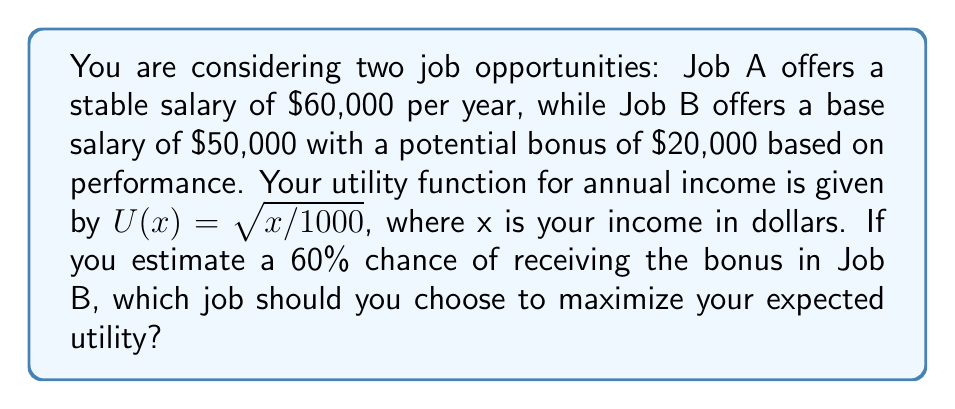Can you solve this math problem? To solve this problem, we need to calculate the expected utility for each job and compare them:

1. Job A:
   - Guaranteed salary: $60,000
   - Utility: $U(60000) = \sqrt{60000/1000} = \sqrt{60} \approx 7.746$

2. Job B:
   - Base salary: $50,000
   - Potential bonus: $20,000
   - Probability of receiving bonus: 60% = 0.6

   We need to consider two scenarios:
   a) With bonus (60% chance):
      Total income: $50,000 + $20,000 = $70,000
      Utility: $U(70000) = \sqrt{70000/1000} = \sqrt{70} \approx 8.367$

   b) Without bonus (40% chance):
      Total income: $50,000
      Utility: $U(50000) = \sqrt{50000/1000} = \sqrt{50} \approx 7.071$

   Expected utility for Job B:
   $E[U(B)] = 0.6 \times U(70000) + 0.4 \times U(50000)$
   $E[U(B)] = 0.6 \times 8.367 + 0.4 \times 7.071 \approx 7.841$

3. Comparing expected utilities:
   Job A: 7.746
   Job B: 7.841

Since the expected utility of Job B (7.841) is higher than the utility of Job A (7.746), you should choose Job B to maximize your expected utility.
Answer: Choose Job B, as it has a higher expected utility of approximately 7.841 compared to Job A's utility of 7.746. 